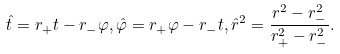Convert formula to latex. <formula><loc_0><loc_0><loc_500><loc_500>\hat { t } = r _ { + } t - r _ { - } \varphi , \hat { \varphi } = r _ { + } \varphi - r _ { - } t , \hat { r } ^ { 2 } = \frac { r ^ { 2 } - r _ { - } ^ { 2 } } { r _ { + } ^ { 2 } - r _ { - } ^ { 2 } } .</formula> 